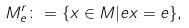Convert formula to latex. <formula><loc_0><loc_0><loc_500><loc_500>M _ { e } ^ { r } \colon = \{ x \in M | e x = e \} ,</formula> 